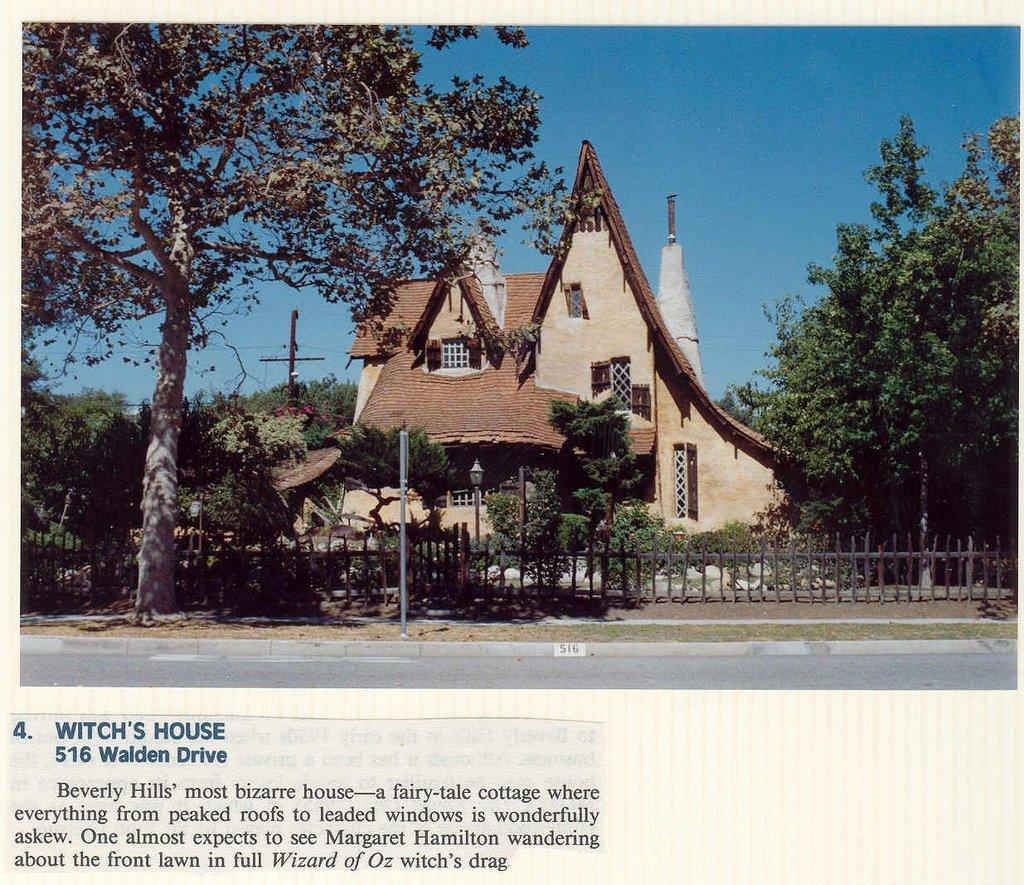What can be found written on the picture? There is text written on the picture. What structures are present in the image? There are poles and a fence in the image. What type of vegetation is visible in the image? There are trees in the image. What type of building is in the image? There is a house in the image. What type of pet is visible in the image? There is no pet present in the image. What type of shoe can be seen on the fence in the image? There is no shoe present in the image. 